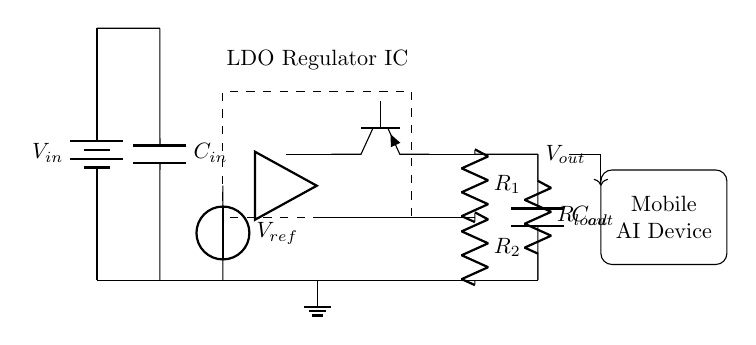What is the input voltage of the circuit? The input voltage is labeled as V_in, which represents the supply voltage for the LDO regulator. It is usually a specified level in the range of operating conditions for the LDO.
Answer: V_in What component smooths the input voltage? The input capacitor, labeled as C_in, is connected between the input voltage and ground. Its purpose is to filter out noise and provide a stable voltage to the LDO.
Answer: C_in What does the dashed box represent? The dashed box contains the LDO regulator IC, which is the main component responsible for providing a regulated output voltage to the load connected to it.
Answer: LDO Regulator IC What is the function of R1 and R2? R1 and R2 form a feedback network that helps in setting the output voltage by comparing it with the reference voltage. The resistive divider adjusts the feedback to maintain a stable output.
Answer: Feedback network Where is the reference voltage generated? The reference voltage is generated by the component labeled V_ref, which provides a stable reference level for the error amplifier inside the LDO to regulate the output voltage.
Answer: V_ref What is the expected output load? The expected output load is represented by R_load, connected in parallel with C_out. It represents the device or circuit that will consume power delivered by the LDO.
Answer: R_load How does the error amplifier influence the output? The error amplifier compares the output voltage with the reference voltage and adjusts the pass transistor's conductance to maintain a stable output voltage. This feedback mechanism is crucial for voltage regulation.
Answer: Error amplifier 